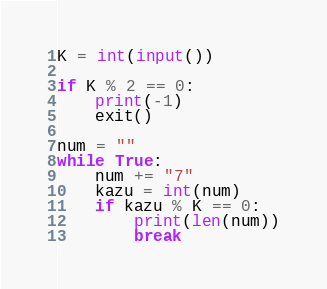<code> <loc_0><loc_0><loc_500><loc_500><_Python_>K = int(input())

if K % 2 == 0:
    print(-1)
    exit()

num = ""
while True:
    num += "7"
    kazu = int(num)
    if kazu % K == 0:
        print(len(num))
        break</code> 